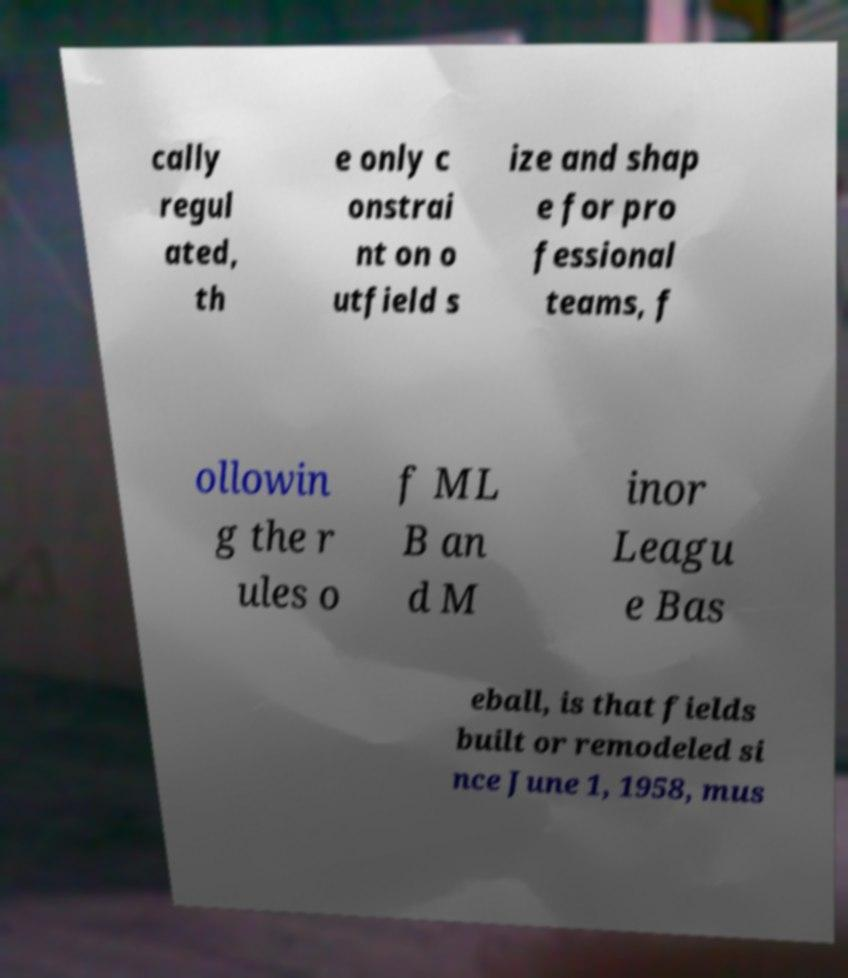There's text embedded in this image that I need extracted. Can you transcribe it verbatim? cally regul ated, th e only c onstrai nt on o utfield s ize and shap e for pro fessional teams, f ollowin g the r ules o f ML B an d M inor Leagu e Bas eball, is that fields built or remodeled si nce June 1, 1958, mus 